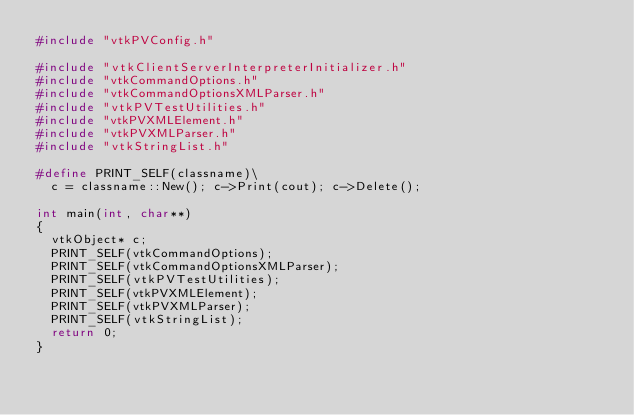<code> <loc_0><loc_0><loc_500><loc_500><_C++_>#include "vtkPVConfig.h"

#include "vtkClientServerInterpreterInitializer.h"
#include "vtkCommandOptions.h"
#include "vtkCommandOptionsXMLParser.h"
#include "vtkPVTestUtilities.h"
#include "vtkPVXMLElement.h"
#include "vtkPVXMLParser.h"
#include "vtkStringList.h"

#define PRINT_SELF(classname)\
  c = classname::New(); c->Print(cout); c->Delete();

int main(int, char**)
{
  vtkObject* c;
  PRINT_SELF(vtkCommandOptions);
  PRINT_SELF(vtkCommandOptionsXMLParser);
  PRINT_SELF(vtkPVTestUtilities);
  PRINT_SELF(vtkPVXMLElement);
  PRINT_SELF(vtkPVXMLParser);
  PRINT_SELF(vtkStringList);
  return 0;
}
</code> 